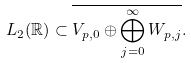<formula> <loc_0><loc_0><loc_500><loc_500>L _ { 2 } ( \mathbb { R } ) \subset \overline { V _ { p , 0 } \oplus \bigoplus _ { j = 0 } ^ { \infty } W _ { p , j } } .</formula> 